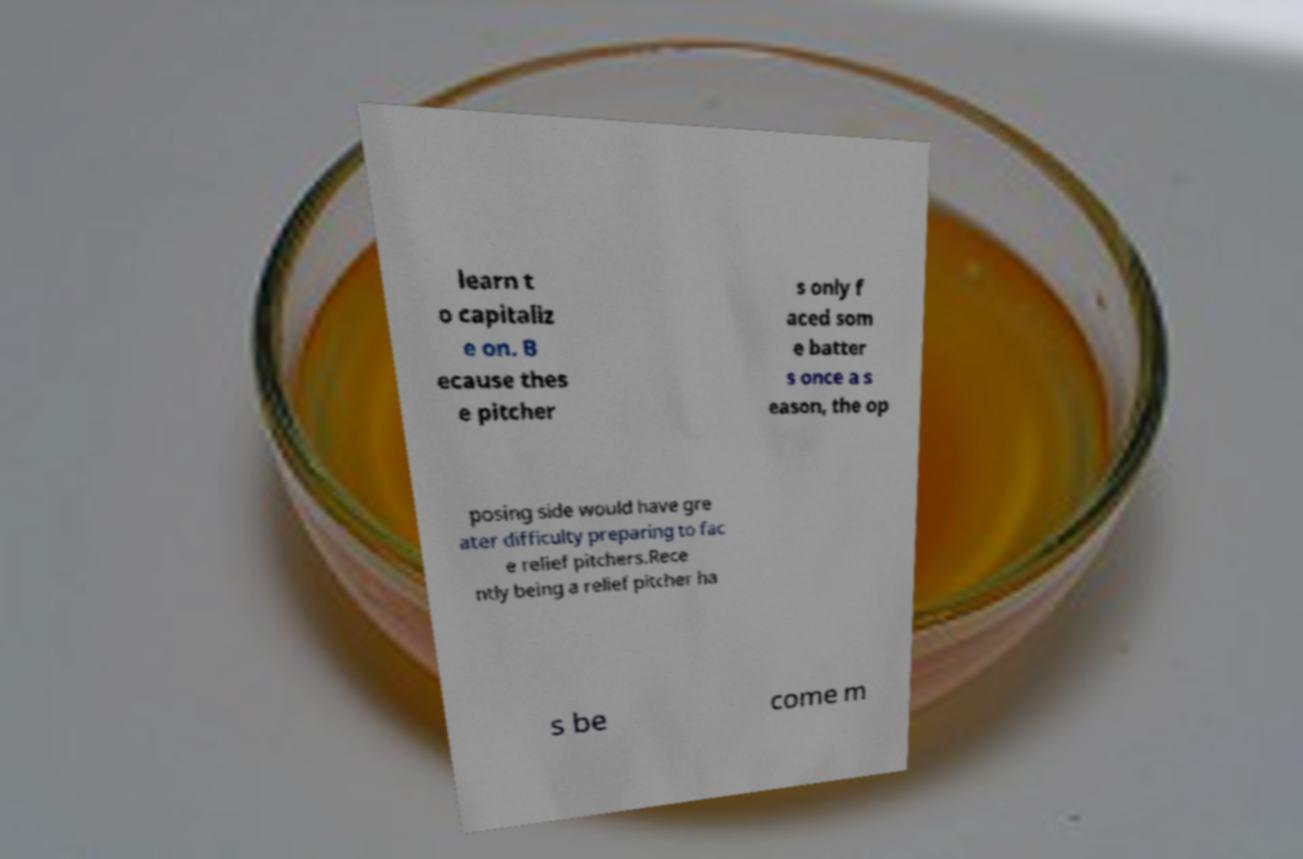I need the written content from this picture converted into text. Can you do that? learn t o capitaliz e on. B ecause thes e pitcher s only f aced som e batter s once a s eason, the op posing side would have gre ater difficulty preparing to fac e relief pitchers.Rece ntly being a relief pitcher ha s be come m 